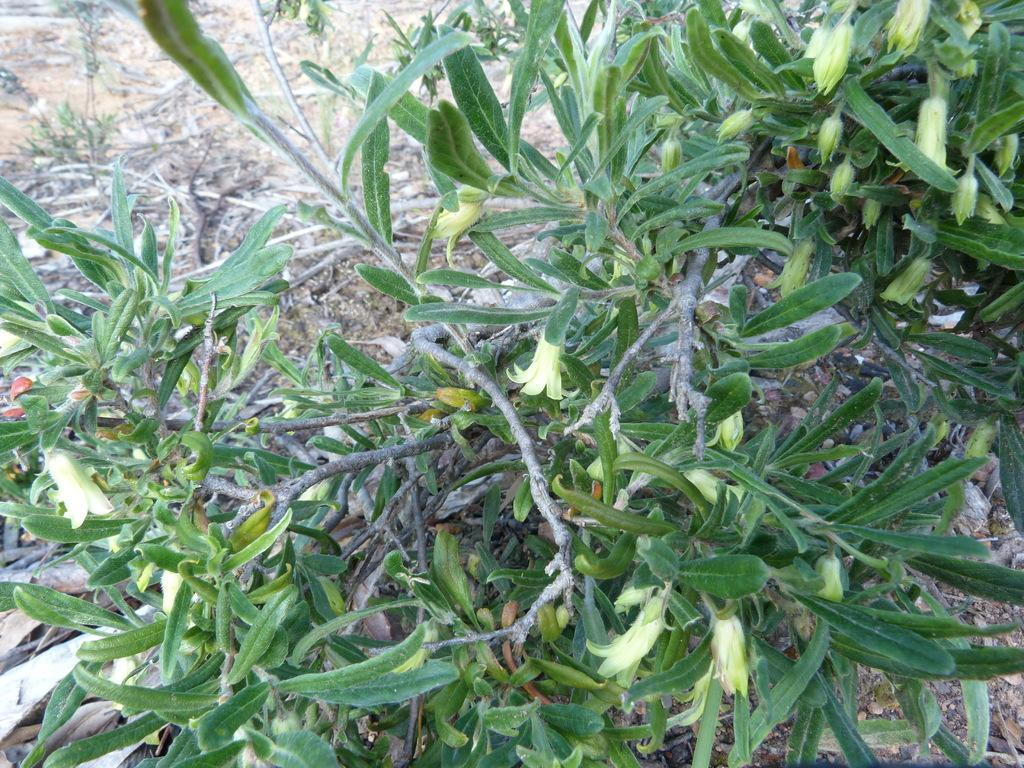What type of living organisms can be seen in the image? Plants can be seen in the image. What stage of growth are the plants in? The plants have flower buds and flowers, indicating that they are in the blooming stage. What is the value of the arithmetic problem written on the plants in the image? There is no arithmetic problem written on the plants in the image. 